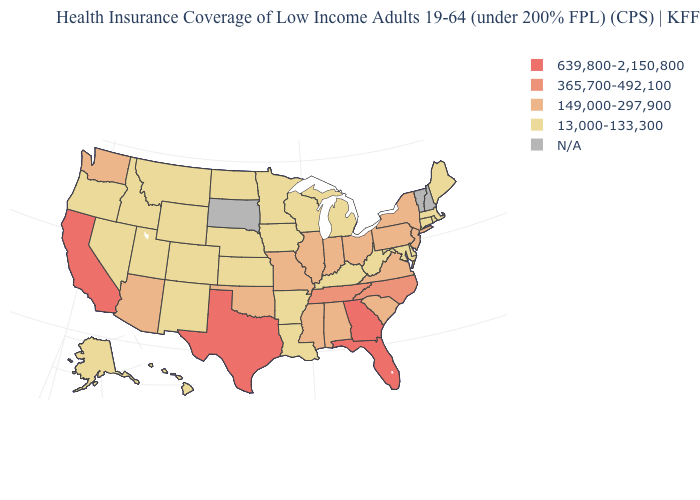Which states hav the highest value in the West?
Quick response, please. California. Name the states that have a value in the range 13,000-133,300?
Keep it brief. Alaska, Arkansas, Colorado, Connecticut, Delaware, Hawaii, Idaho, Iowa, Kansas, Kentucky, Louisiana, Maine, Maryland, Massachusetts, Michigan, Minnesota, Montana, Nebraska, Nevada, New Mexico, North Dakota, Oregon, Rhode Island, Utah, West Virginia, Wisconsin, Wyoming. What is the lowest value in the USA?
Keep it brief. 13,000-133,300. Does Nebraska have the highest value in the MidWest?
Give a very brief answer. No. Does the map have missing data?
Give a very brief answer. Yes. Does New York have the highest value in the Northeast?
Answer briefly. Yes. Name the states that have a value in the range 639,800-2,150,800?
Be succinct. California, Florida, Georgia, Texas. Which states hav the highest value in the MidWest?
Write a very short answer. Illinois, Indiana, Missouri, Ohio. Which states have the lowest value in the Northeast?
Keep it brief. Connecticut, Maine, Massachusetts, Rhode Island. Name the states that have a value in the range 639,800-2,150,800?
Short answer required. California, Florida, Georgia, Texas. Name the states that have a value in the range 639,800-2,150,800?
Answer briefly. California, Florida, Georgia, Texas. What is the value of Utah?
Keep it brief. 13,000-133,300. Does Iowa have the lowest value in the USA?
Answer briefly. Yes. 